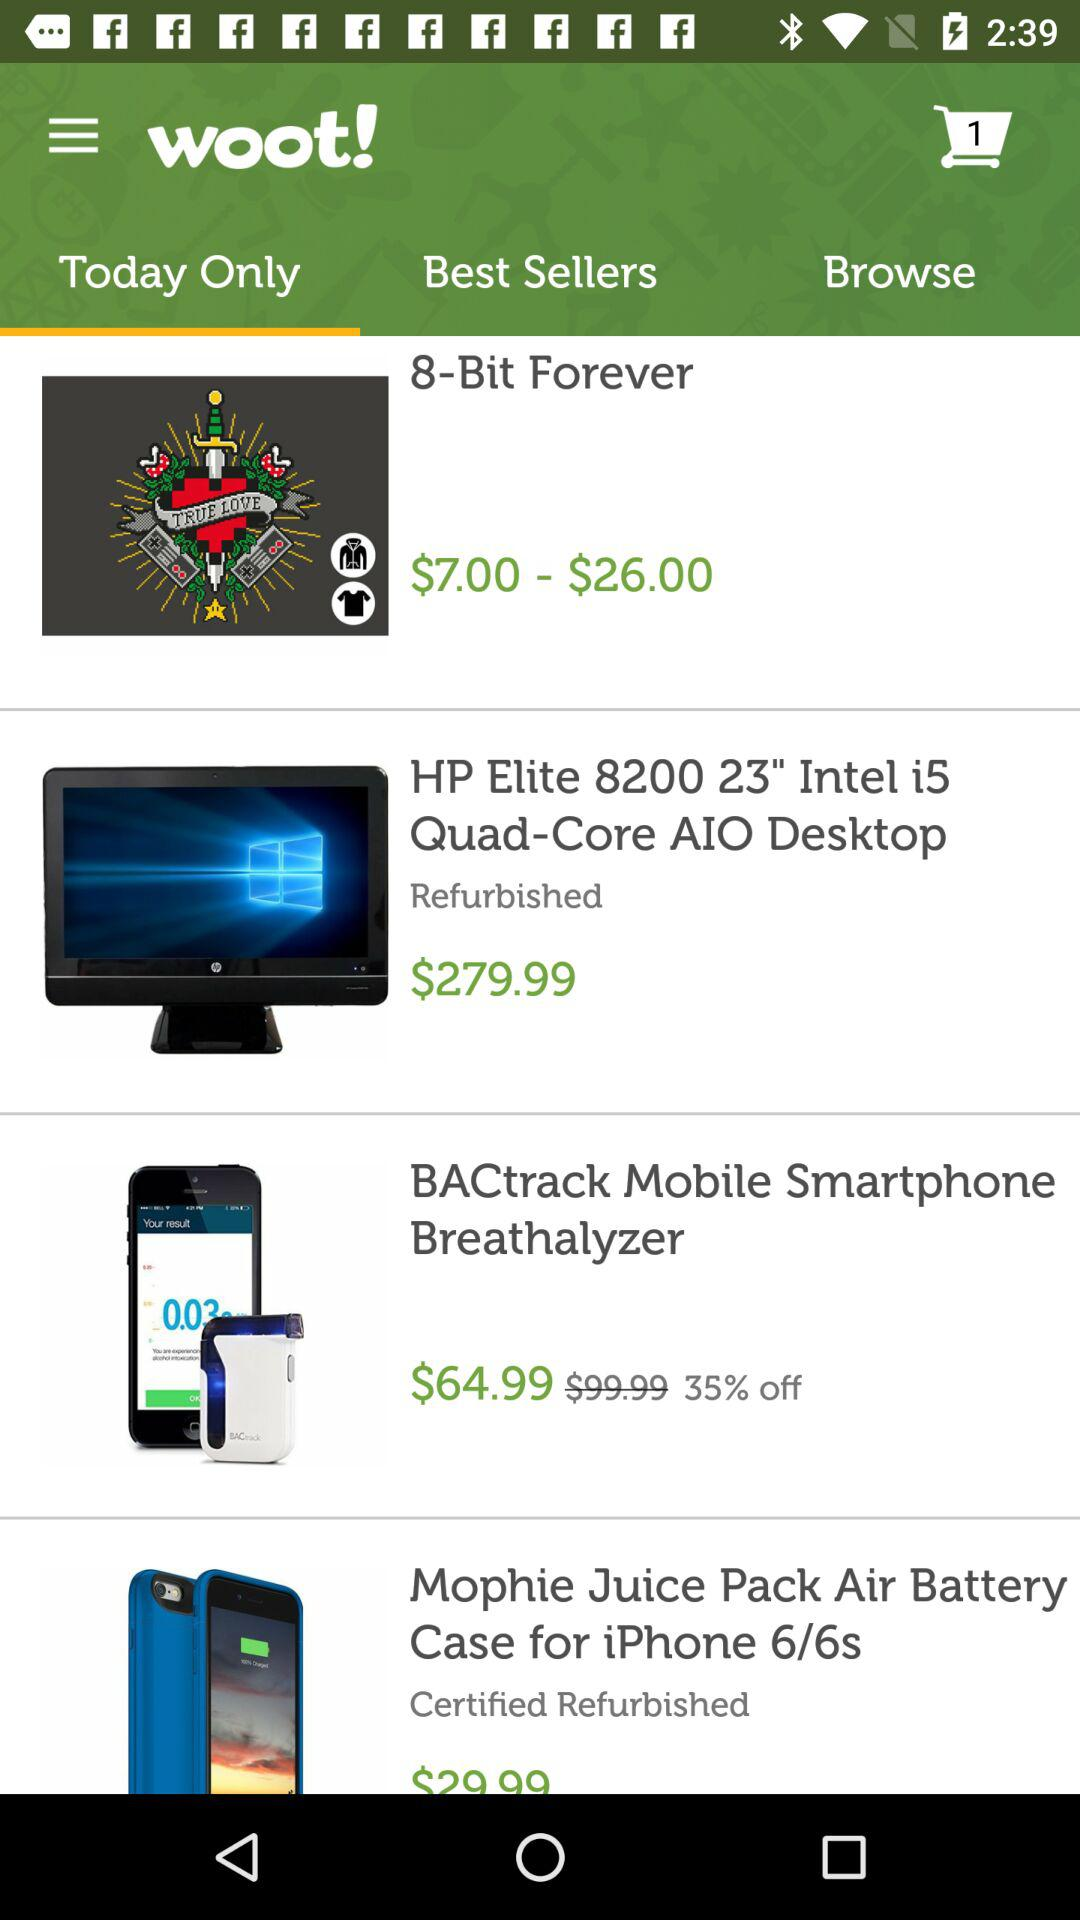What is the price of the "HP Elite 8200"? The price of the "HP Elite 8200" is $279.99. 